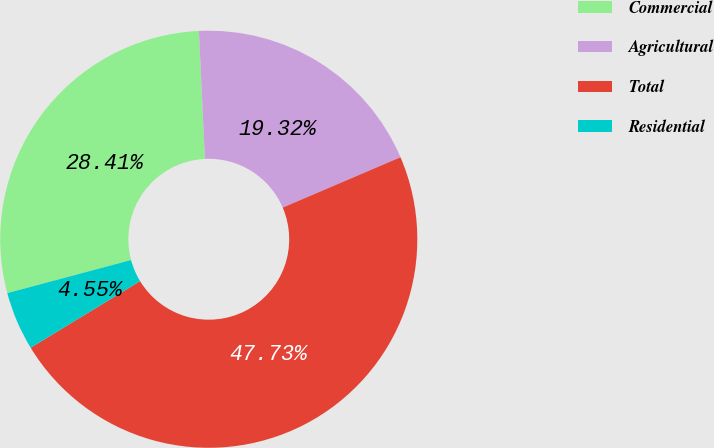Convert chart to OTSL. <chart><loc_0><loc_0><loc_500><loc_500><pie_chart><fcel>Commercial<fcel>Agricultural<fcel>Total<fcel>Residential<nl><fcel>28.41%<fcel>19.32%<fcel>47.73%<fcel>4.55%<nl></chart> 